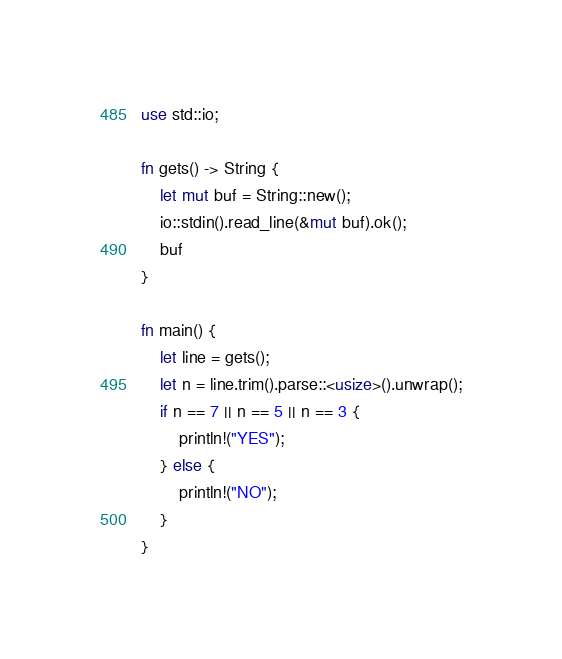Convert code to text. <code><loc_0><loc_0><loc_500><loc_500><_Rust_>use std::io;

fn gets() -> String {
    let mut buf = String::new();
    io::stdin().read_line(&mut buf).ok();
    buf
}

fn main() {
    let line = gets();
    let n = line.trim().parse::<usize>().unwrap();
    if n == 7 || n == 5 || n == 3 {
        println!("YES");
    } else {
        println!("NO");
    }
}
</code> 